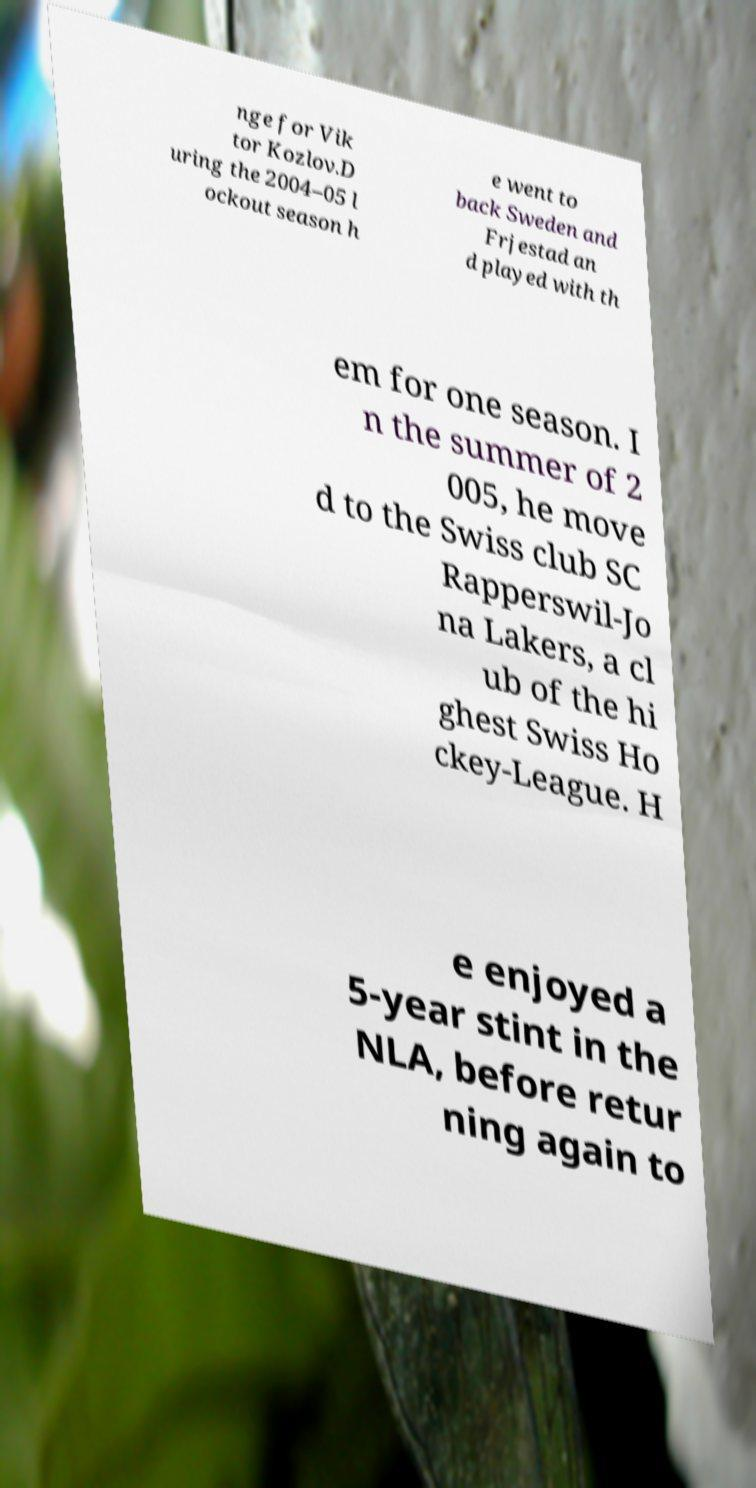Could you assist in decoding the text presented in this image and type it out clearly? nge for Vik tor Kozlov.D uring the 2004–05 l ockout season h e went to back Sweden and Frjestad an d played with th em for one season. I n the summer of 2 005, he move d to the Swiss club SC Rapperswil-Jo na Lakers, a cl ub of the hi ghest Swiss Ho ckey-League. H e enjoyed a 5-year stint in the NLA, before retur ning again to 